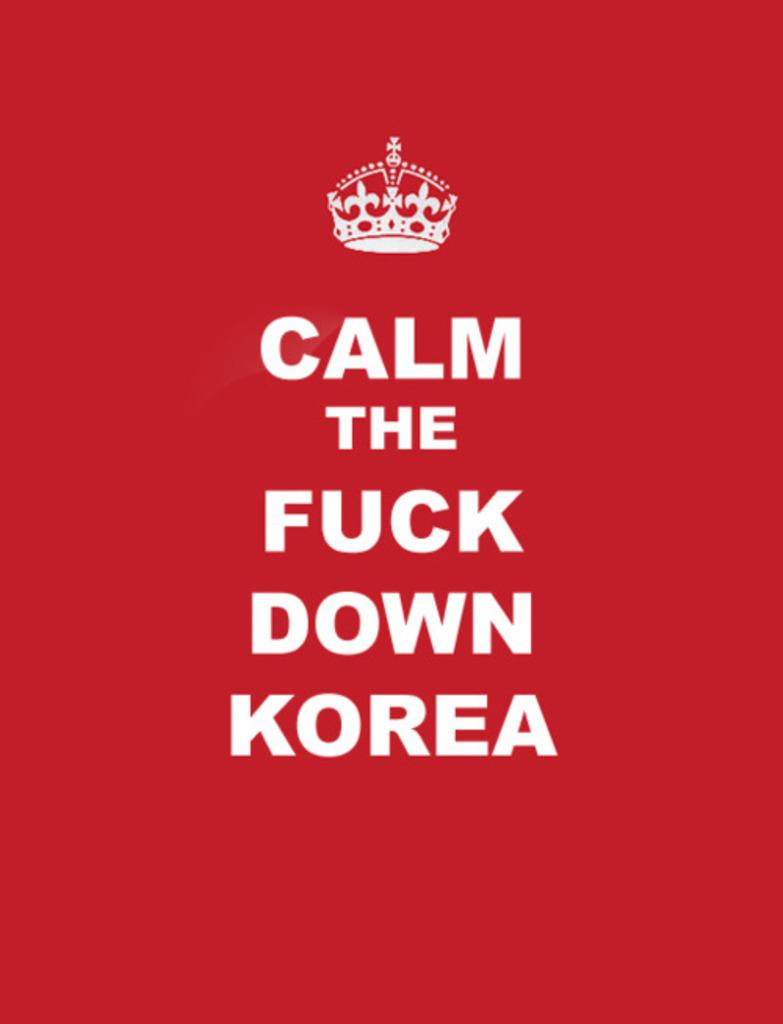What is featured in the image? There is a poster in the image. What can be found on the poster? The poster contains a logo and text. What type of soap is advertised on the poster in the image? There is no soap advertised on the poster in the image; it contains a logo and text, but no reference to soap. 